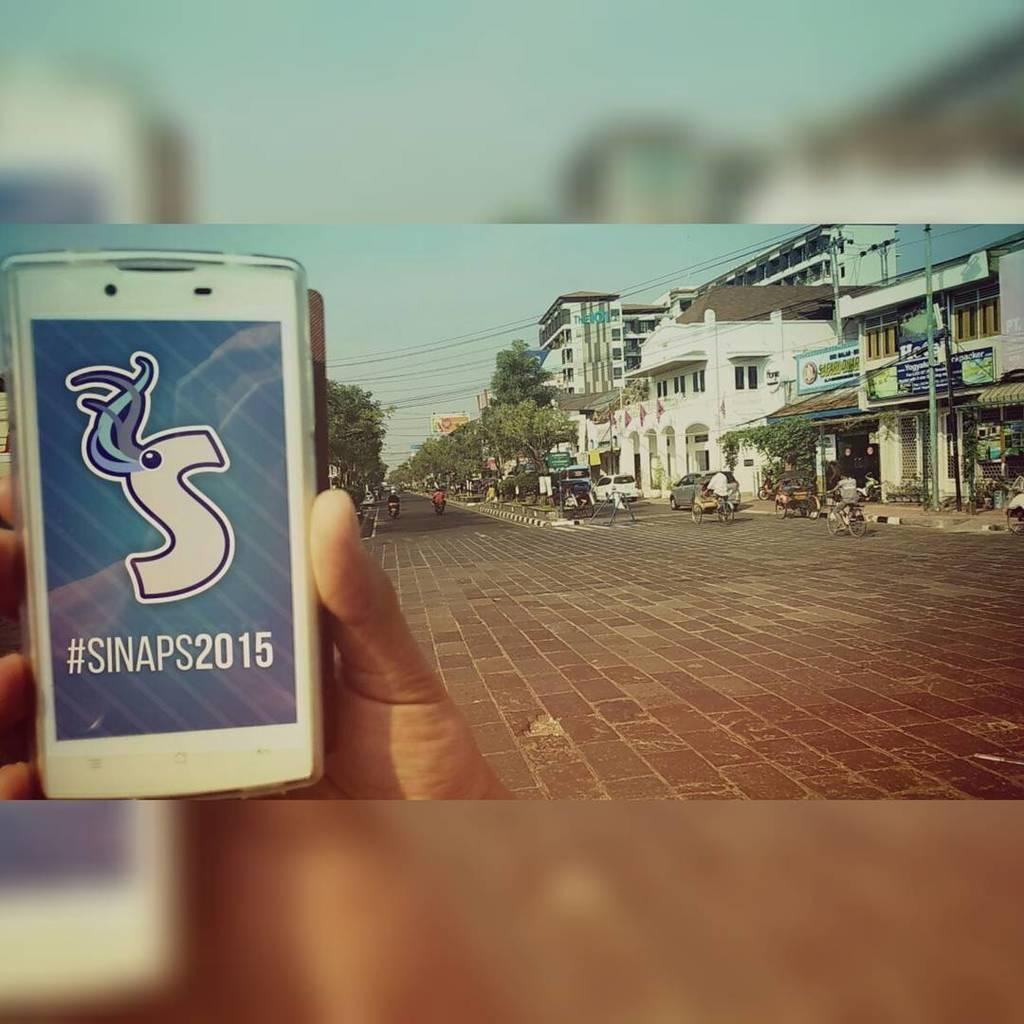Provide a one-sentence caption for the provided image. A phone with the words #SINAPS2015 is being held in front of an empty street. 